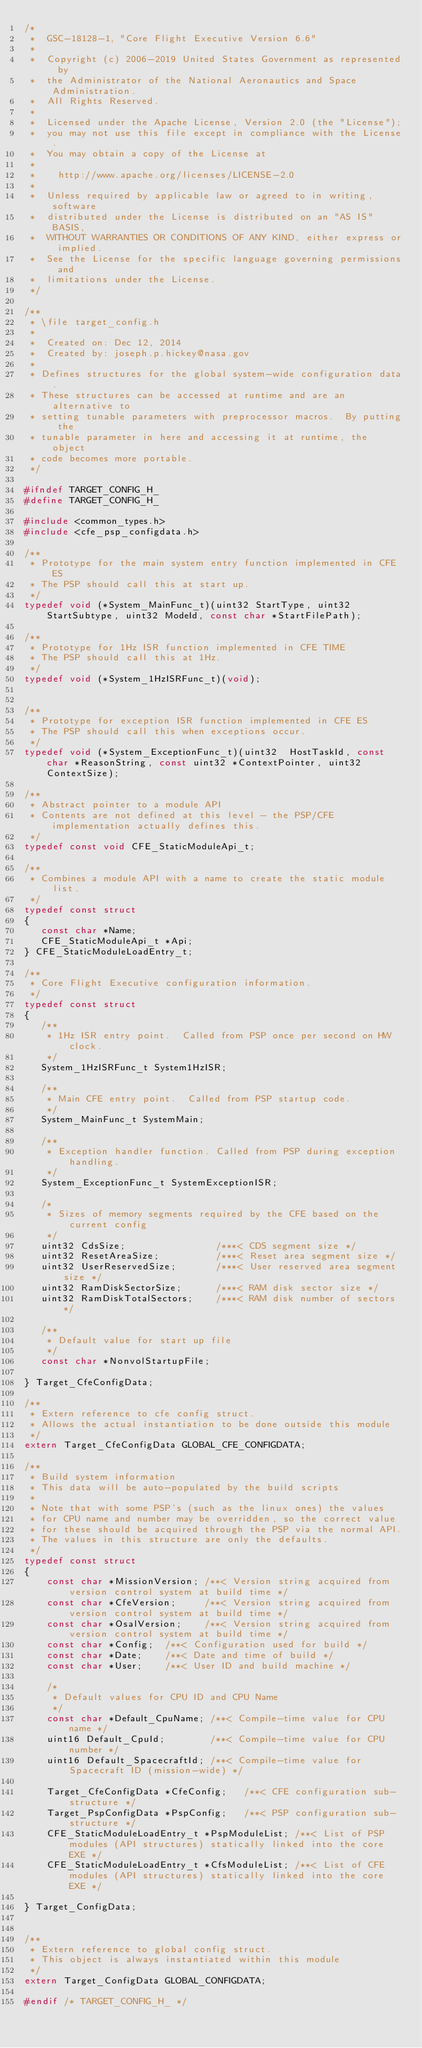<code> <loc_0><loc_0><loc_500><loc_500><_C_>/*
 *  GSC-18128-1, "Core Flight Executive Version 6.6"
 *
 *  Copyright (c) 2006-2019 United States Government as represented by
 *  the Administrator of the National Aeronautics and Space Administration.
 *  All Rights Reserved.
 *
 *  Licensed under the Apache License, Version 2.0 (the "License");
 *  you may not use this file except in compliance with the License.
 *  You may obtain a copy of the License at
 *
 *    http://www.apache.org/licenses/LICENSE-2.0
 *
 *  Unless required by applicable law or agreed to in writing, software
 *  distributed under the License is distributed on an "AS IS" BASIS,
 *  WITHOUT WARRANTIES OR CONDITIONS OF ANY KIND, either express or implied.
 *  See the License for the specific language governing permissions and
 *  limitations under the License.
 */

/**
 * \file target_config.h
 *
 *  Created on: Dec 12, 2014
 *  Created by: joseph.p.hickey@nasa.gov
 *
 * Defines structures for the global system-wide configuration data.
 * These structures can be accessed at runtime and are an alternative to
 * setting tunable parameters with preprocessor macros.  By putting the
 * tunable parameter in here and accessing it at runtime, the object
 * code becomes more portable.
 */

#ifndef TARGET_CONFIG_H_
#define TARGET_CONFIG_H_

#include <common_types.h>
#include <cfe_psp_configdata.h>

/**
 * Prototype for the main system entry function implemented in CFE ES
 * The PSP should call this at start up.
 */
typedef void (*System_MainFunc_t)(uint32 StartType, uint32 StartSubtype, uint32 ModeId, const char *StartFilePath);

/**
 * Prototype for 1Hz ISR function implemented in CFE TIME
 * The PSP should call this at 1Hz.
 */
typedef void (*System_1HzISRFunc_t)(void);


/**
 * Prototype for exception ISR function implemented in CFE ES
 * The PSP should call this when exceptions occur.
 */
typedef void (*System_ExceptionFunc_t)(uint32  HostTaskId, const char *ReasonString, const uint32 *ContextPointer, uint32 ContextSize);

/**
 * Abstract pointer to a module API
 * Contents are not defined at this level - the PSP/CFE implementation actually defines this.
 */
typedef const void CFE_StaticModuleApi_t;

/**
 * Combines a module API with a name to create the static module list.
 */
typedef const struct
{
   const char *Name;
   CFE_StaticModuleApi_t *Api;
} CFE_StaticModuleLoadEntry_t;

/**
 * Core Flight Executive configuration information.
 */
typedef const struct
{
   /**
    * 1Hz ISR entry point.  Called from PSP once per second on HW clock.
    */
   System_1HzISRFunc_t System1HzISR;

   /**
    * Main CFE entry point.  Called from PSP startup code.
    */
   System_MainFunc_t SystemMain;

   /**
    * Exception handler function. Called from PSP during exception handling.
    */
   System_ExceptionFunc_t SystemExceptionISR;

   /*
    * Sizes of memory segments required by the CFE based on the current config
    */
   uint32 CdsSize;                /***< CDS segment size */
   uint32 ResetAreaSize;          /***< Reset area segment size */
   uint32 UserReservedSize;       /***< User reserved area segment size */
   uint32 RamDiskSectorSize;      /***< RAM disk sector size */
   uint32 RamDiskTotalSectors;    /***< RAM disk number of sectors */

   /**
    * Default value for start up file
    */
   const char *NonvolStartupFile;

} Target_CfeConfigData;

/**
 * Extern reference to cfe config struct.
 * Allows the actual instantiation to be done outside this module
 */
extern Target_CfeConfigData GLOBAL_CFE_CONFIGDATA;

/**
 * Build system information
 * This data will be auto-populated by the build scripts
 *
 * Note that with some PSP's (such as the linux ones) the values
 * for CPU name and number may be overridden, so the correct value
 * for these should be acquired through the PSP via the normal API.
 * The values in this structure are only the defaults.
 */
typedef const struct
{
    const char *MissionVersion; /**< Version string acquired from version control system at build time */
    const char *CfeVersion;     /**< Version string acquired from version control system at build time */
    const char *OsalVersion;    /**< Version string acquired from version control system at build time */
    const char *Config;  /**< Configuration used for build */
    const char *Date;    /**< Date and time of build */
    const char *User;    /**< User ID and build machine */

    /*
     * Default values for CPU ID and CPU Name
     */
    const char *Default_CpuName; /**< Compile-time value for CPU name */
    uint16 Default_CpuId;        /**< Compile-time value for CPU number */
    uint16 Default_SpacecraftId; /**< Compile-time value for Spacecraft ID (mission-wide) */

    Target_CfeConfigData *CfeConfig;   /**< CFE configuration sub-structure */
    Target_PspConfigData *PspConfig;   /**< PSP configuration sub-structure */
    CFE_StaticModuleLoadEntry_t *PspModuleList; /**< List of PSP modules (API structures) statically linked into the core EXE */
    CFE_StaticModuleLoadEntry_t *CfsModuleList; /**< List of CFE modules (API structures) statically linked into the core EXE */

} Target_ConfigData;


/**
 * Extern reference to global config struct.
 * This object is always instantiated within this module
 */
extern Target_ConfigData GLOBAL_CONFIGDATA;

#endif /* TARGET_CONFIG_H_ */
</code> 